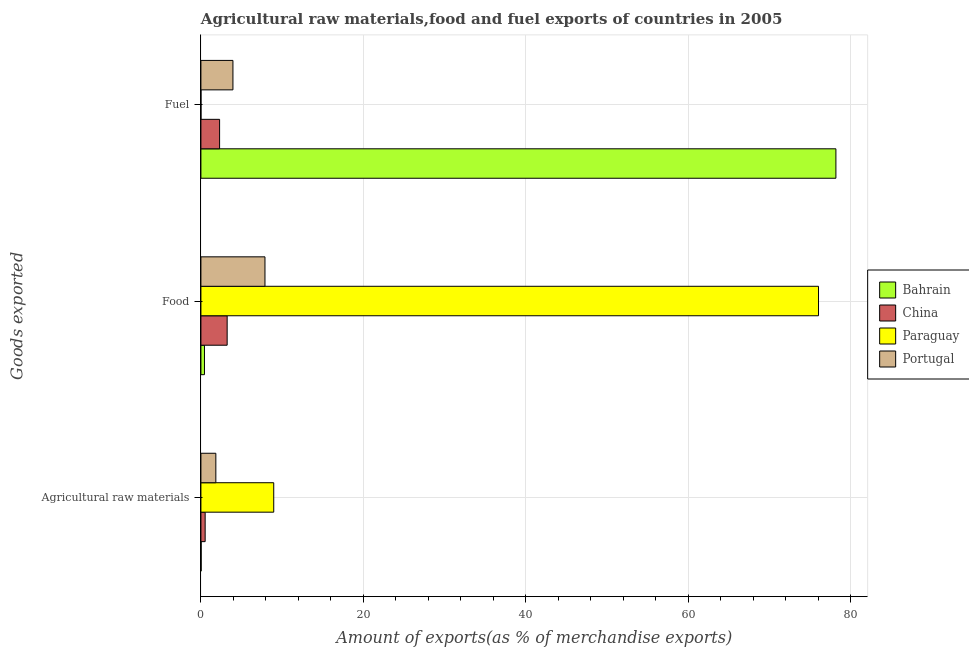Are the number of bars per tick equal to the number of legend labels?
Your answer should be compact. Yes. What is the label of the 3rd group of bars from the top?
Offer a very short reply. Agricultural raw materials. What is the percentage of fuel exports in Bahrain?
Your answer should be compact. 78.16. Across all countries, what is the maximum percentage of raw materials exports?
Give a very brief answer. 8.96. Across all countries, what is the minimum percentage of fuel exports?
Your answer should be compact. 0. In which country was the percentage of raw materials exports maximum?
Give a very brief answer. Paraguay. In which country was the percentage of food exports minimum?
Your answer should be very brief. Bahrain. What is the total percentage of fuel exports in the graph?
Provide a succinct answer. 84.4. What is the difference between the percentage of food exports in Portugal and that in Bahrain?
Offer a very short reply. 7.45. What is the difference between the percentage of raw materials exports in Paraguay and the percentage of fuel exports in Portugal?
Give a very brief answer. 5.02. What is the average percentage of fuel exports per country?
Offer a terse response. 21.1. What is the difference between the percentage of raw materials exports and percentage of fuel exports in China?
Give a very brief answer. -1.78. In how many countries, is the percentage of fuel exports greater than 20 %?
Give a very brief answer. 1. What is the ratio of the percentage of fuel exports in Bahrain to that in Portugal?
Your answer should be very brief. 19.83. Is the percentage of raw materials exports in China less than that in Paraguay?
Make the answer very short. Yes. Is the difference between the percentage of fuel exports in Paraguay and Portugal greater than the difference between the percentage of food exports in Paraguay and Portugal?
Ensure brevity in your answer.  No. What is the difference between the highest and the second highest percentage of raw materials exports?
Make the answer very short. 7.13. What is the difference between the highest and the lowest percentage of raw materials exports?
Make the answer very short. 8.93. What does the 4th bar from the top in Agricultural raw materials represents?
Provide a succinct answer. Bahrain. What does the 3rd bar from the bottom in Food represents?
Offer a terse response. Paraguay. Are all the bars in the graph horizontal?
Keep it short and to the point. Yes. How many countries are there in the graph?
Keep it short and to the point. 4. What is the difference between two consecutive major ticks on the X-axis?
Give a very brief answer. 20. Does the graph contain any zero values?
Your answer should be compact. No. Does the graph contain grids?
Your response must be concise. Yes. Where does the legend appear in the graph?
Your response must be concise. Center right. How many legend labels are there?
Your response must be concise. 4. What is the title of the graph?
Provide a short and direct response. Agricultural raw materials,food and fuel exports of countries in 2005. What is the label or title of the X-axis?
Your answer should be compact. Amount of exports(as % of merchandise exports). What is the label or title of the Y-axis?
Provide a short and direct response. Goods exported. What is the Amount of exports(as % of merchandise exports) of Bahrain in Agricultural raw materials?
Provide a succinct answer. 0.03. What is the Amount of exports(as % of merchandise exports) of China in Agricultural raw materials?
Your answer should be very brief. 0.52. What is the Amount of exports(as % of merchandise exports) in Paraguay in Agricultural raw materials?
Provide a short and direct response. 8.96. What is the Amount of exports(as % of merchandise exports) of Portugal in Agricultural raw materials?
Keep it short and to the point. 1.84. What is the Amount of exports(as % of merchandise exports) in Bahrain in Food?
Your answer should be compact. 0.44. What is the Amount of exports(as % of merchandise exports) of China in Food?
Your response must be concise. 3.23. What is the Amount of exports(as % of merchandise exports) of Paraguay in Food?
Ensure brevity in your answer.  76.02. What is the Amount of exports(as % of merchandise exports) in Portugal in Food?
Your response must be concise. 7.88. What is the Amount of exports(as % of merchandise exports) of Bahrain in Fuel?
Provide a succinct answer. 78.16. What is the Amount of exports(as % of merchandise exports) of China in Fuel?
Your answer should be very brief. 2.3. What is the Amount of exports(as % of merchandise exports) of Paraguay in Fuel?
Make the answer very short. 0. What is the Amount of exports(as % of merchandise exports) of Portugal in Fuel?
Make the answer very short. 3.94. Across all Goods exported, what is the maximum Amount of exports(as % of merchandise exports) of Bahrain?
Offer a very short reply. 78.16. Across all Goods exported, what is the maximum Amount of exports(as % of merchandise exports) in China?
Your answer should be very brief. 3.23. Across all Goods exported, what is the maximum Amount of exports(as % of merchandise exports) in Paraguay?
Your answer should be compact. 76.02. Across all Goods exported, what is the maximum Amount of exports(as % of merchandise exports) of Portugal?
Make the answer very short. 7.88. Across all Goods exported, what is the minimum Amount of exports(as % of merchandise exports) of Bahrain?
Your answer should be compact. 0.03. Across all Goods exported, what is the minimum Amount of exports(as % of merchandise exports) of China?
Make the answer very short. 0.52. Across all Goods exported, what is the minimum Amount of exports(as % of merchandise exports) in Paraguay?
Give a very brief answer. 0. Across all Goods exported, what is the minimum Amount of exports(as % of merchandise exports) of Portugal?
Your response must be concise. 1.84. What is the total Amount of exports(as % of merchandise exports) in Bahrain in the graph?
Provide a succinct answer. 78.63. What is the total Amount of exports(as % of merchandise exports) in China in the graph?
Make the answer very short. 6.05. What is the total Amount of exports(as % of merchandise exports) in Paraguay in the graph?
Ensure brevity in your answer.  84.98. What is the total Amount of exports(as % of merchandise exports) of Portugal in the graph?
Your answer should be compact. 13.66. What is the difference between the Amount of exports(as % of merchandise exports) of Bahrain in Agricultural raw materials and that in Food?
Offer a terse response. -0.41. What is the difference between the Amount of exports(as % of merchandise exports) of China in Agricultural raw materials and that in Food?
Provide a short and direct response. -2.71. What is the difference between the Amount of exports(as % of merchandise exports) of Paraguay in Agricultural raw materials and that in Food?
Provide a succinct answer. -67.06. What is the difference between the Amount of exports(as % of merchandise exports) in Portugal in Agricultural raw materials and that in Food?
Provide a short and direct response. -6.05. What is the difference between the Amount of exports(as % of merchandise exports) of Bahrain in Agricultural raw materials and that in Fuel?
Your response must be concise. -78.13. What is the difference between the Amount of exports(as % of merchandise exports) in China in Agricultural raw materials and that in Fuel?
Provide a succinct answer. -1.78. What is the difference between the Amount of exports(as % of merchandise exports) in Paraguay in Agricultural raw materials and that in Fuel?
Your answer should be compact. 8.96. What is the difference between the Amount of exports(as % of merchandise exports) of Portugal in Agricultural raw materials and that in Fuel?
Offer a very short reply. -2.1. What is the difference between the Amount of exports(as % of merchandise exports) in Bahrain in Food and that in Fuel?
Provide a succinct answer. -77.72. What is the difference between the Amount of exports(as % of merchandise exports) in China in Food and that in Fuel?
Your answer should be very brief. 0.93. What is the difference between the Amount of exports(as % of merchandise exports) in Paraguay in Food and that in Fuel?
Offer a very short reply. 76.02. What is the difference between the Amount of exports(as % of merchandise exports) of Portugal in Food and that in Fuel?
Ensure brevity in your answer.  3.94. What is the difference between the Amount of exports(as % of merchandise exports) in Bahrain in Agricultural raw materials and the Amount of exports(as % of merchandise exports) in China in Food?
Your response must be concise. -3.2. What is the difference between the Amount of exports(as % of merchandise exports) in Bahrain in Agricultural raw materials and the Amount of exports(as % of merchandise exports) in Paraguay in Food?
Provide a succinct answer. -75.99. What is the difference between the Amount of exports(as % of merchandise exports) in Bahrain in Agricultural raw materials and the Amount of exports(as % of merchandise exports) in Portugal in Food?
Your response must be concise. -7.85. What is the difference between the Amount of exports(as % of merchandise exports) in China in Agricultural raw materials and the Amount of exports(as % of merchandise exports) in Paraguay in Food?
Provide a succinct answer. -75.5. What is the difference between the Amount of exports(as % of merchandise exports) of China in Agricultural raw materials and the Amount of exports(as % of merchandise exports) of Portugal in Food?
Ensure brevity in your answer.  -7.36. What is the difference between the Amount of exports(as % of merchandise exports) in Paraguay in Agricultural raw materials and the Amount of exports(as % of merchandise exports) in Portugal in Food?
Provide a succinct answer. 1.08. What is the difference between the Amount of exports(as % of merchandise exports) in Bahrain in Agricultural raw materials and the Amount of exports(as % of merchandise exports) in China in Fuel?
Give a very brief answer. -2.27. What is the difference between the Amount of exports(as % of merchandise exports) in Bahrain in Agricultural raw materials and the Amount of exports(as % of merchandise exports) in Paraguay in Fuel?
Provide a short and direct response. 0.03. What is the difference between the Amount of exports(as % of merchandise exports) in Bahrain in Agricultural raw materials and the Amount of exports(as % of merchandise exports) in Portugal in Fuel?
Make the answer very short. -3.91. What is the difference between the Amount of exports(as % of merchandise exports) in China in Agricultural raw materials and the Amount of exports(as % of merchandise exports) in Paraguay in Fuel?
Keep it short and to the point. 0.52. What is the difference between the Amount of exports(as % of merchandise exports) in China in Agricultural raw materials and the Amount of exports(as % of merchandise exports) in Portugal in Fuel?
Give a very brief answer. -3.42. What is the difference between the Amount of exports(as % of merchandise exports) in Paraguay in Agricultural raw materials and the Amount of exports(as % of merchandise exports) in Portugal in Fuel?
Provide a succinct answer. 5.02. What is the difference between the Amount of exports(as % of merchandise exports) of Bahrain in Food and the Amount of exports(as % of merchandise exports) of China in Fuel?
Provide a short and direct response. -1.86. What is the difference between the Amount of exports(as % of merchandise exports) of Bahrain in Food and the Amount of exports(as % of merchandise exports) of Paraguay in Fuel?
Give a very brief answer. 0.43. What is the difference between the Amount of exports(as % of merchandise exports) of Bahrain in Food and the Amount of exports(as % of merchandise exports) of Portugal in Fuel?
Offer a very short reply. -3.5. What is the difference between the Amount of exports(as % of merchandise exports) in China in Food and the Amount of exports(as % of merchandise exports) in Paraguay in Fuel?
Make the answer very short. 3.23. What is the difference between the Amount of exports(as % of merchandise exports) in China in Food and the Amount of exports(as % of merchandise exports) in Portugal in Fuel?
Make the answer very short. -0.71. What is the difference between the Amount of exports(as % of merchandise exports) in Paraguay in Food and the Amount of exports(as % of merchandise exports) in Portugal in Fuel?
Your answer should be compact. 72.08. What is the average Amount of exports(as % of merchandise exports) in Bahrain per Goods exported?
Your answer should be compact. 26.21. What is the average Amount of exports(as % of merchandise exports) in China per Goods exported?
Your answer should be compact. 2.02. What is the average Amount of exports(as % of merchandise exports) in Paraguay per Goods exported?
Provide a succinct answer. 28.33. What is the average Amount of exports(as % of merchandise exports) in Portugal per Goods exported?
Ensure brevity in your answer.  4.55. What is the difference between the Amount of exports(as % of merchandise exports) in Bahrain and Amount of exports(as % of merchandise exports) in China in Agricultural raw materials?
Your answer should be very brief. -0.49. What is the difference between the Amount of exports(as % of merchandise exports) of Bahrain and Amount of exports(as % of merchandise exports) of Paraguay in Agricultural raw materials?
Offer a terse response. -8.93. What is the difference between the Amount of exports(as % of merchandise exports) in Bahrain and Amount of exports(as % of merchandise exports) in Portugal in Agricultural raw materials?
Ensure brevity in your answer.  -1.81. What is the difference between the Amount of exports(as % of merchandise exports) of China and Amount of exports(as % of merchandise exports) of Paraguay in Agricultural raw materials?
Provide a short and direct response. -8.44. What is the difference between the Amount of exports(as % of merchandise exports) in China and Amount of exports(as % of merchandise exports) in Portugal in Agricultural raw materials?
Your answer should be very brief. -1.31. What is the difference between the Amount of exports(as % of merchandise exports) of Paraguay and Amount of exports(as % of merchandise exports) of Portugal in Agricultural raw materials?
Keep it short and to the point. 7.13. What is the difference between the Amount of exports(as % of merchandise exports) of Bahrain and Amount of exports(as % of merchandise exports) of China in Food?
Give a very brief answer. -2.79. What is the difference between the Amount of exports(as % of merchandise exports) of Bahrain and Amount of exports(as % of merchandise exports) of Paraguay in Food?
Your response must be concise. -75.58. What is the difference between the Amount of exports(as % of merchandise exports) of Bahrain and Amount of exports(as % of merchandise exports) of Portugal in Food?
Provide a succinct answer. -7.45. What is the difference between the Amount of exports(as % of merchandise exports) in China and Amount of exports(as % of merchandise exports) in Paraguay in Food?
Offer a very short reply. -72.79. What is the difference between the Amount of exports(as % of merchandise exports) in China and Amount of exports(as % of merchandise exports) in Portugal in Food?
Make the answer very short. -4.65. What is the difference between the Amount of exports(as % of merchandise exports) in Paraguay and Amount of exports(as % of merchandise exports) in Portugal in Food?
Your answer should be compact. 68.14. What is the difference between the Amount of exports(as % of merchandise exports) of Bahrain and Amount of exports(as % of merchandise exports) of China in Fuel?
Ensure brevity in your answer.  75.86. What is the difference between the Amount of exports(as % of merchandise exports) in Bahrain and Amount of exports(as % of merchandise exports) in Paraguay in Fuel?
Give a very brief answer. 78.16. What is the difference between the Amount of exports(as % of merchandise exports) of Bahrain and Amount of exports(as % of merchandise exports) of Portugal in Fuel?
Your answer should be compact. 74.22. What is the difference between the Amount of exports(as % of merchandise exports) in China and Amount of exports(as % of merchandise exports) in Paraguay in Fuel?
Offer a very short reply. 2.3. What is the difference between the Amount of exports(as % of merchandise exports) of China and Amount of exports(as % of merchandise exports) of Portugal in Fuel?
Keep it short and to the point. -1.64. What is the difference between the Amount of exports(as % of merchandise exports) in Paraguay and Amount of exports(as % of merchandise exports) in Portugal in Fuel?
Offer a very short reply. -3.94. What is the ratio of the Amount of exports(as % of merchandise exports) in Bahrain in Agricultural raw materials to that in Food?
Ensure brevity in your answer.  0.07. What is the ratio of the Amount of exports(as % of merchandise exports) of China in Agricultural raw materials to that in Food?
Provide a short and direct response. 0.16. What is the ratio of the Amount of exports(as % of merchandise exports) in Paraguay in Agricultural raw materials to that in Food?
Your response must be concise. 0.12. What is the ratio of the Amount of exports(as % of merchandise exports) in Portugal in Agricultural raw materials to that in Food?
Your response must be concise. 0.23. What is the ratio of the Amount of exports(as % of merchandise exports) in China in Agricultural raw materials to that in Fuel?
Offer a very short reply. 0.23. What is the ratio of the Amount of exports(as % of merchandise exports) in Paraguay in Agricultural raw materials to that in Fuel?
Provide a short and direct response. 3776.83. What is the ratio of the Amount of exports(as % of merchandise exports) in Portugal in Agricultural raw materials to that in Fuel?
Your answer should be compact. 0.47. What is the ratio of the Amount of exports(as % of merchandise exports) of Bahrain in Food to that in Fuel?
Your answer should be very brief. 0.01. What is the ratio of the Amount of exports(as % of merchandise exports) of China in Food to that in Fuel?
Make the answer very short. 1.4. What is the ratio of the Amount of exports(as % of merchandise exports) of Paraguay in Food to that in Fuel?
Provide a short and direct response. 3.20e+04. What is the ratio of the Amount of exports(as % of merchandise exports) in Portugal in Food to that in Fuel?
Your response must be concise. 2. What is the difference between the highest and the second highest Amount of exports(as % of merchandise exports) in Bahrain?
Give a very brief answer. 77.72. What is the difference between the highest and the second highest Amount of exports(as % of merchandise exports) of China?
Your response must be concise. 0.93. What is the difference between the highest and the second highest Amount of exports(as % of merchandise exports) in Paraguay?
Your response must be concise. 67.06. What is the difference between the highest and the second highest Amount of exports(as % of merchandise exports) in Portugal?
Offer a very short reply. 3.94. What is the difference between the highest and the lowest Amount of exports(as % of merchandise exports) of Bahrain?
Your response must be concise. 78.13. What is the difference between the highest and the lowest Amount of exports(as % of merchandise exports) of China?
Keep it short and to the point. 2.71. What is the difference between the highest and the lowest Amount of exports(as % of merchandise exports) of Paraguay?
Keep it short and to the point. 76.02. What is the difference between the highest and the lowest Amount of exports(as % of merchandise exports) in Portugal?
Give a very brief answer. 6.05. 